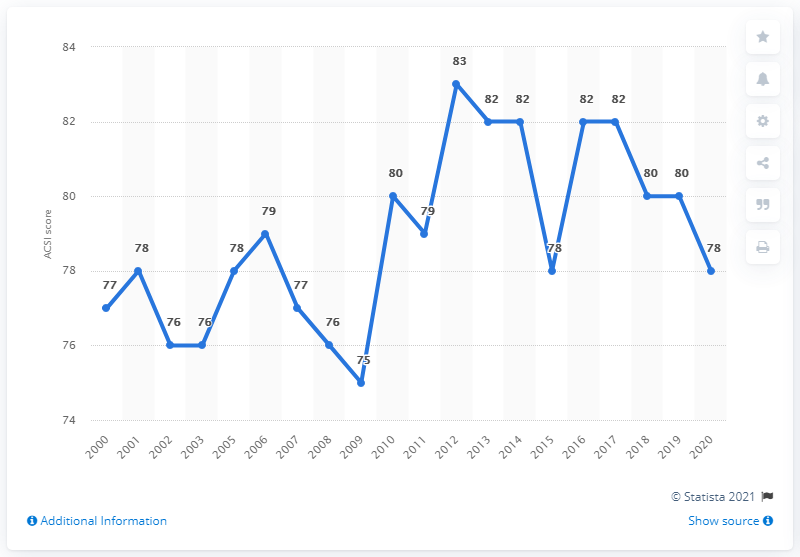Specify some key components in this picture. Papa John's received a score of 78 on the American Customer Satisfaction Index, indicating a relatively high level of customer satisfaction. 